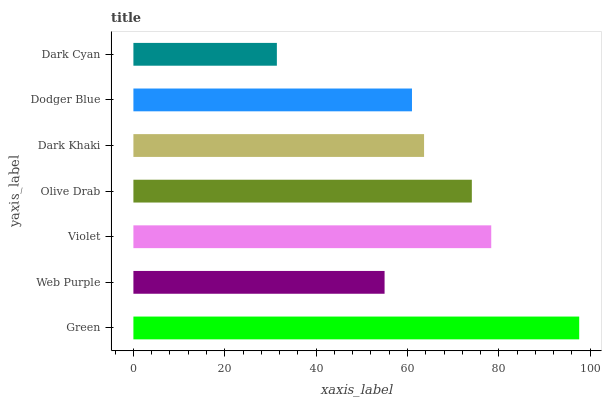Is Dark Cyan the minimum?
Answer yes or no. Yes. Is Green the maximum?
Answer yes or no. Yes. Is Web Purple the minimum?
Answer yes or no. No. Is Web Purple the maximum?
Answer yes or no. No. Is Green greater than Web Purple?
Answer yes or no. Yes. Is Web Purple less than Green?
Answer yes or no. Yes. Is Web Purple greater than Green?
Answer yes or no. No. Is Green less than Web Purple?
Answer yes or no. No. Is Dark Khaki the high median?
Answer yes or no. Yes. Is Dark Khaki the low median?
Answer yes or no. Yes. Is Web Purple the high median?
Answer yes or no. No. Is Dodger Blue the low median?
Answer yes or no. No. 